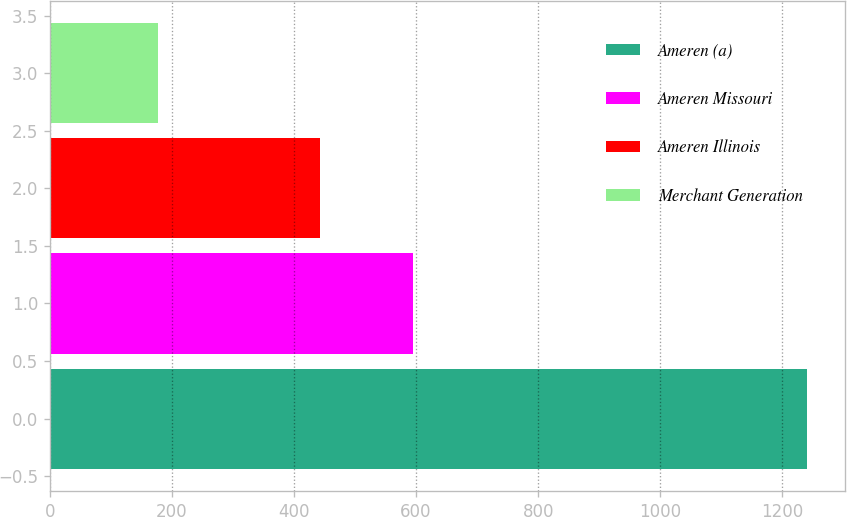<chart> <loc_0><loc_0><loc_500><loc_500><bar_chart><fcel>Ameren (a)<fcel>Ameren Missouri<fcel>Ameren Illinois<fcel>Merchant Generation<nl><fcel>1240<fcel>595<fcel>442<fcel>178<nl></chart> 